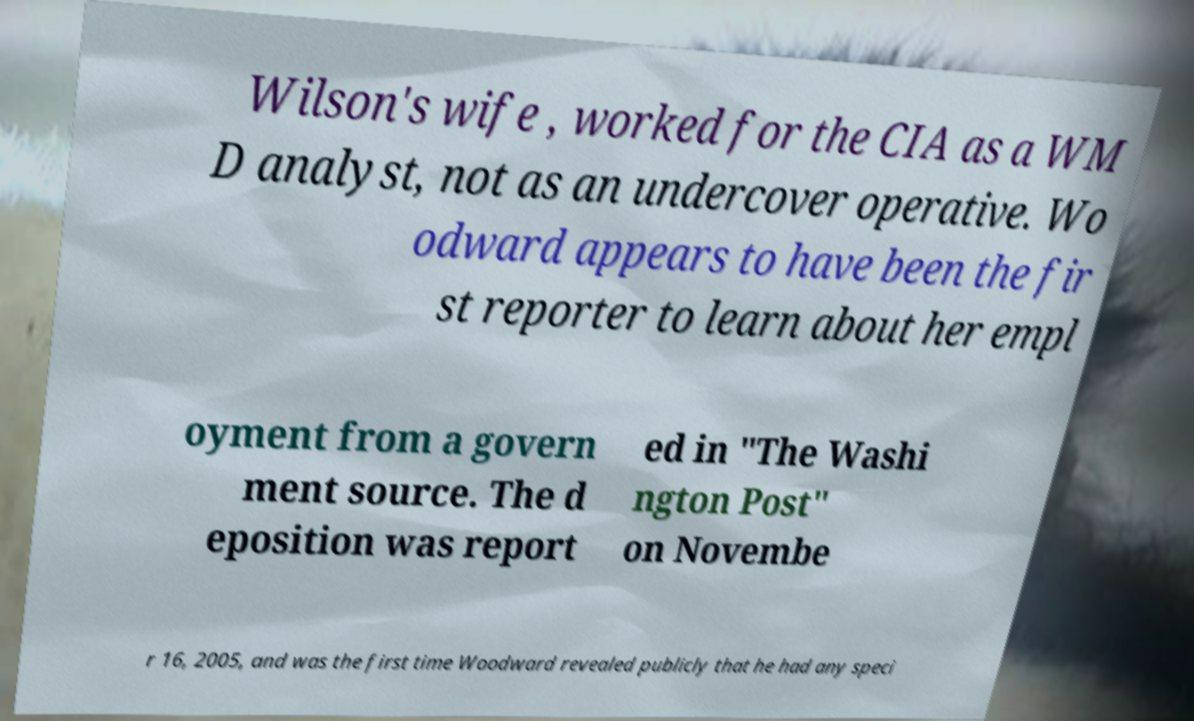Please identify and transcribe the text found in this image. Wilson's wife , worked for the CIA as a WM D analyst, not as an undercover operative. Wo odward appears to have been the fir st reporter to learn about her empl oyment from a govern ment source. The d eposition was report ed in "The Washi ngton Post" on Novembe r 16, 2005, and was the first time Woodward revealed publicly that he had any speci 